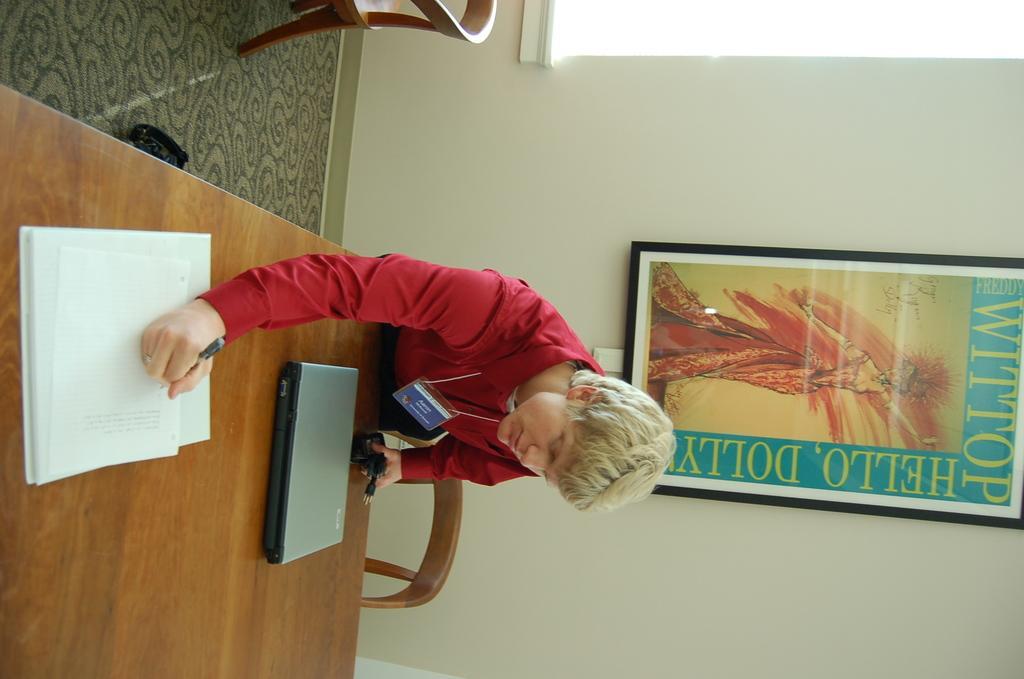Please provide a concise description of this image. In this image, I can see the man standing and writing on a paper. This is the wooden table with a laptop and a book on it. I can see a chair. This is a photo frame, which is attached to the wall. At the top of the image, I can see another chair. I think this is the floor. 